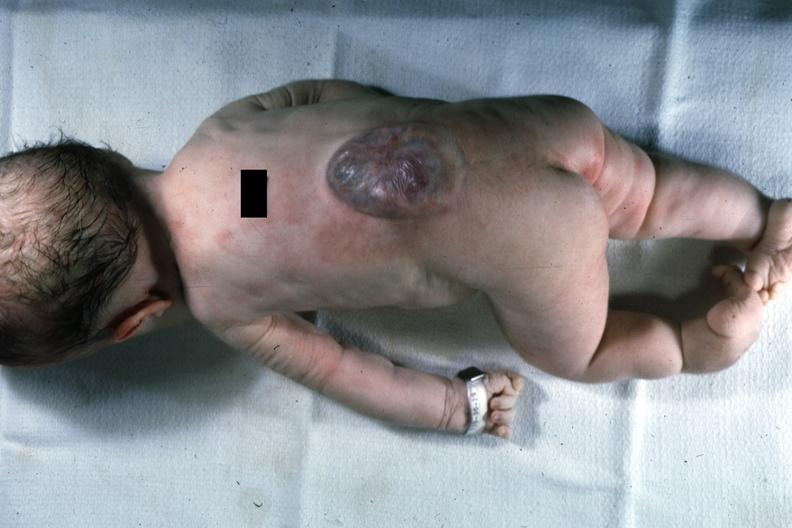s typical tuberculous exudate present?
Answer the question using a single word or phrase. No 